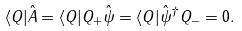<formula> <loc_0><loc_0><loc_500><loc_500>\langle Q | \hat { A } = \langle Q | Q _ { + } \hat { \psi } = \langle Q | \hat { \psi } ^ { \dagger } Q _ { - } = 0 .</formula> 